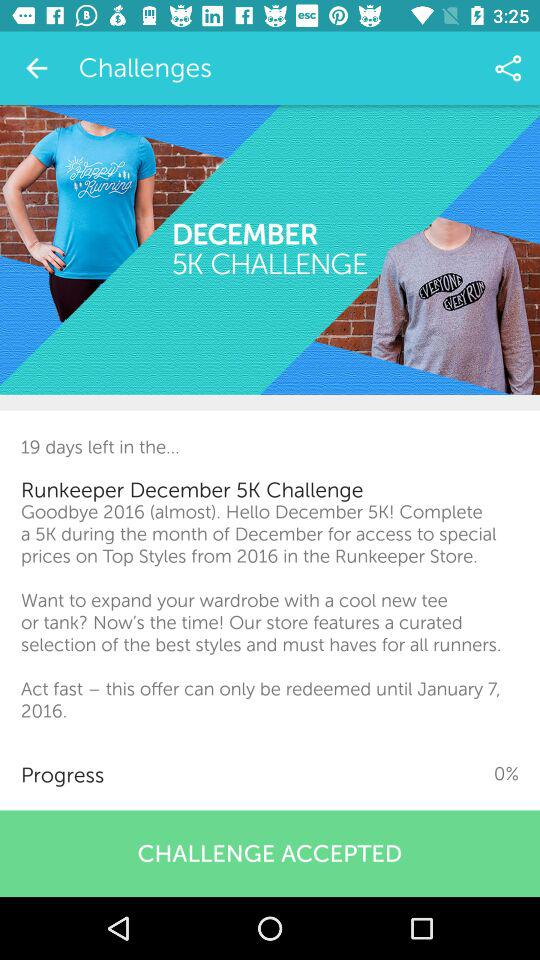Until when can this offer only be redeemed? This offer can only be redeemed until January 7, 2016. 